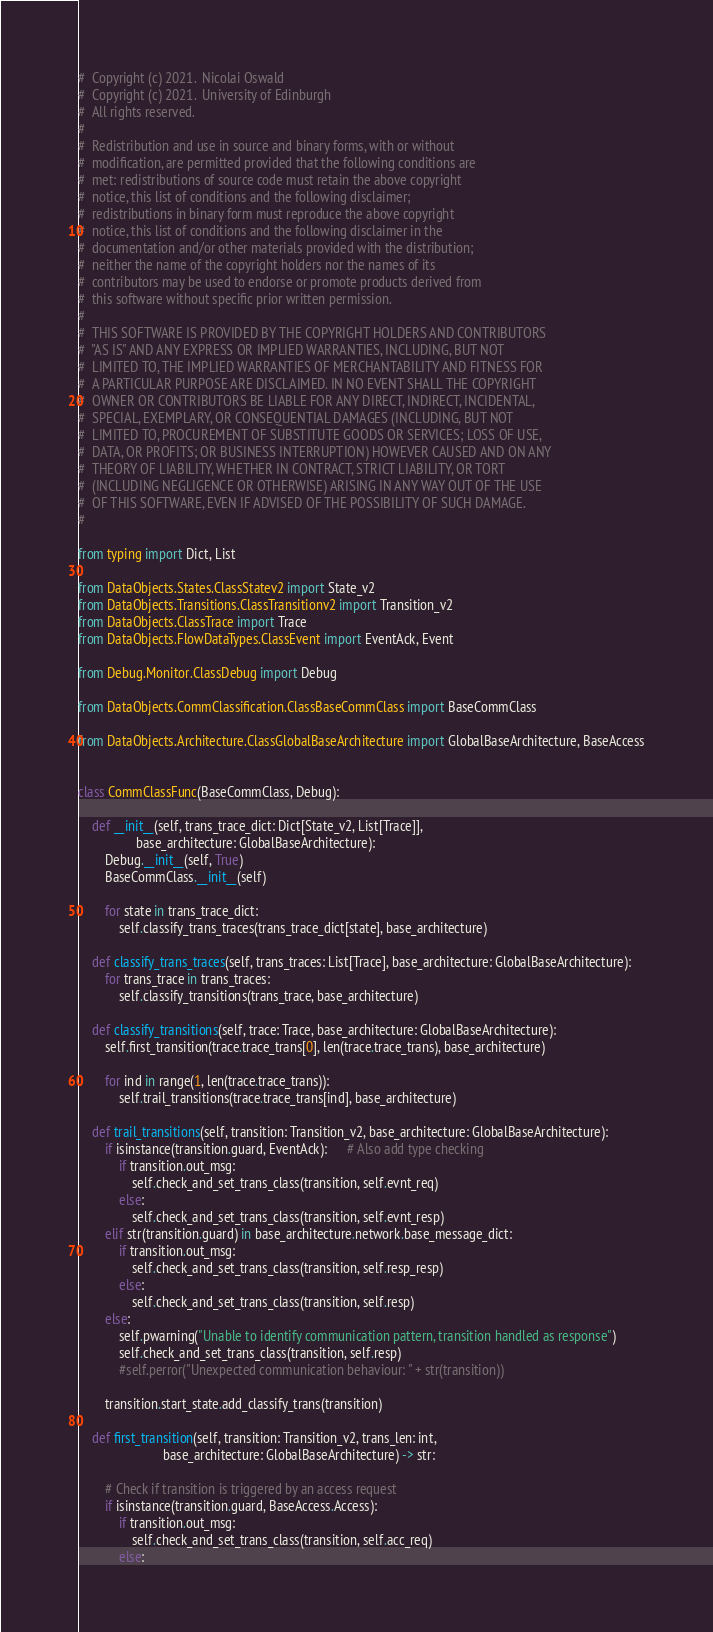<code> <loc_0><loc_0><loc_500><loc_500><_Python_>#  Copyright (c) 2021.  Nicolai Oswald
#  Copyright (c) 2021.  University of Edinburgh
#  All rights reserved.
# 
#  Redistribution and use in source and binary forms, with or without
#  modification, are permitted provided that the following conditions are
#  met: redistributions of source code must retain the above copyright
#  notice, this list of conditions and the following disclaimer;
#  redistributions in binary form must reproduce the above copyright
#  notice, this list of conditions and the following disclaimer in the
#  documentation and/or other materials provided with the distribution;
#  neither the name of the copyright holders nor the names of its
#  contributors may be used to endorse or promote products derived from
#  this software without specific prior written permission.
# 
#  THIS SOFTWARE IS PROVIDED BY THE COPYRIGHT HOLDERS AND CONTRIBUTORS
#  "AS IS" AND ANY EXPRESS OR IMPLIED WARRANTIES, INCLUDING, BUT NOT
#  LIMITED TO, THE IMPLIED WARRANTIES OF MERCHANTABILITY AND FITNESS FOR
#  A PARTICULAR PURPOSE ARE DISCLAIMED. IN NO EVENT SHALL THE COPYRIGHT
#  OWNER OR CONTRIBUTORS BE LIABLE FOR ANY DIRECT, INDIRECT, INCIDENTAL,
#  SPECIAL, EXEMPLARY, OR CONSEQUENTIAL DAMAGES (INCLUDING, BUT NOT
#  LIMITED TO, PROCUREMENT OF SUBSTITUTE GOODS OR SERVICES; LOSS OF USE,
#  DATA, OR PROFITS; OR BUSINESS INTERRUPTION) HOWEVER CAUSED AND ON ANY
#  THEORY OF LIABILITY, WHETHER IN CONTRACT, STRICT LIABILITY, OR TORT
#  (INCLUDING NEGLIGENCE OR OTHERWISE) ARISING IN ANY WAY OUT OF THE USE
#  OF THIS SOFTWARE, EVEN IF ADVISED OF THE POSSIBILITY OF SUCH DAMAGE.
# 

from typing import Dict, List

from DataObjects.States.ClassStatev2 import State_v2
from DataObjects.Transitions.ClassTransitionv2 import Transition_v2
from DataObjects.ClassTrace import Trace
from DataObjects.FlowDataTypes.ClassEvent import EventAck, Event

from Debug.Monitor.ClassDebug import Debug

from DataObjects.CommClassification.ClassBaseCommClass import BaseCommClass

from DataObjects.Architecture.ClassGlobalBaseArchitecture import GlobalBaseArchitecture, BaseAccess


class CommClassFunc(BaseCommClass, Debug):

    def __init__(self, trans_trace_dict: Dict[State_v2, List[Trace]],
                 base_architecture: GlobalBaseArchitecture):
        Debug.__init__(self, True)
        BaseCommClass.__init__(self)

        for state in trans_trace_dict:
            self.classify_trans_traces(trans_trace_dict[state], base_architecture)

    def classify_trans_traces(self, trans_traces: List[Trace], base_architecture: GlobalBaseArchitecture):
        for trans_trace in trans_traces:
            self.classify_transitions(trans_trace, base_architecture)

    def classify_transitions(self, trace: Trace, base_architecture: GlobalBaseArchitecture):
        self.first_transition(trace.trace_trans[0], len(trace.trace_trans), base_architecture)

        for ind in range(1, len(trace.trace_trans)):
            self.trail_transitions(trace.trace_trans[ind], base_architecture)

    def trail_transitions(self, transition: Transition_v2, base_architecture: GlobalBaseArchitecture):
        if isinstance(transition.guard, EventAck):      # Also add type checking
            if transition.out_msg:
                self.check_and_set_trans_class(transition, self.evnt_req)
            else:
                self.check_and_set_trans_class(transition, self.evnt_resp)
        elif str(transition.guard) in base_architecture.network.base_message_dict:
            if transition.out_msg:
                self.check_and_set_trans_class(transition, self.resp_resp)
            else:
                self.check_and_set_trans_class(transition, self.resp)
        else:
            self.pwarning("Unable to identify communication pattern, transition handled as response")
            self.check_and_set_trans_class(transition, self.resp)
            #self.perror("Unexpected communication behaviour: " + str(transition))

        transition.start_state.add_classify_trans(transition)

    def first_transition(self, transition: Transition_v2, trans_len: int,
                         base_architecture: GlobalBaseArchitecture) -> str:

        # Check if transition is triggered by an access request
        if isinstance(transition.guard, BaseAccess.Access):
            if transition.out_msg:
                self.check_and_set_trans_class(transition, self.acc_req)
            else:</code> 